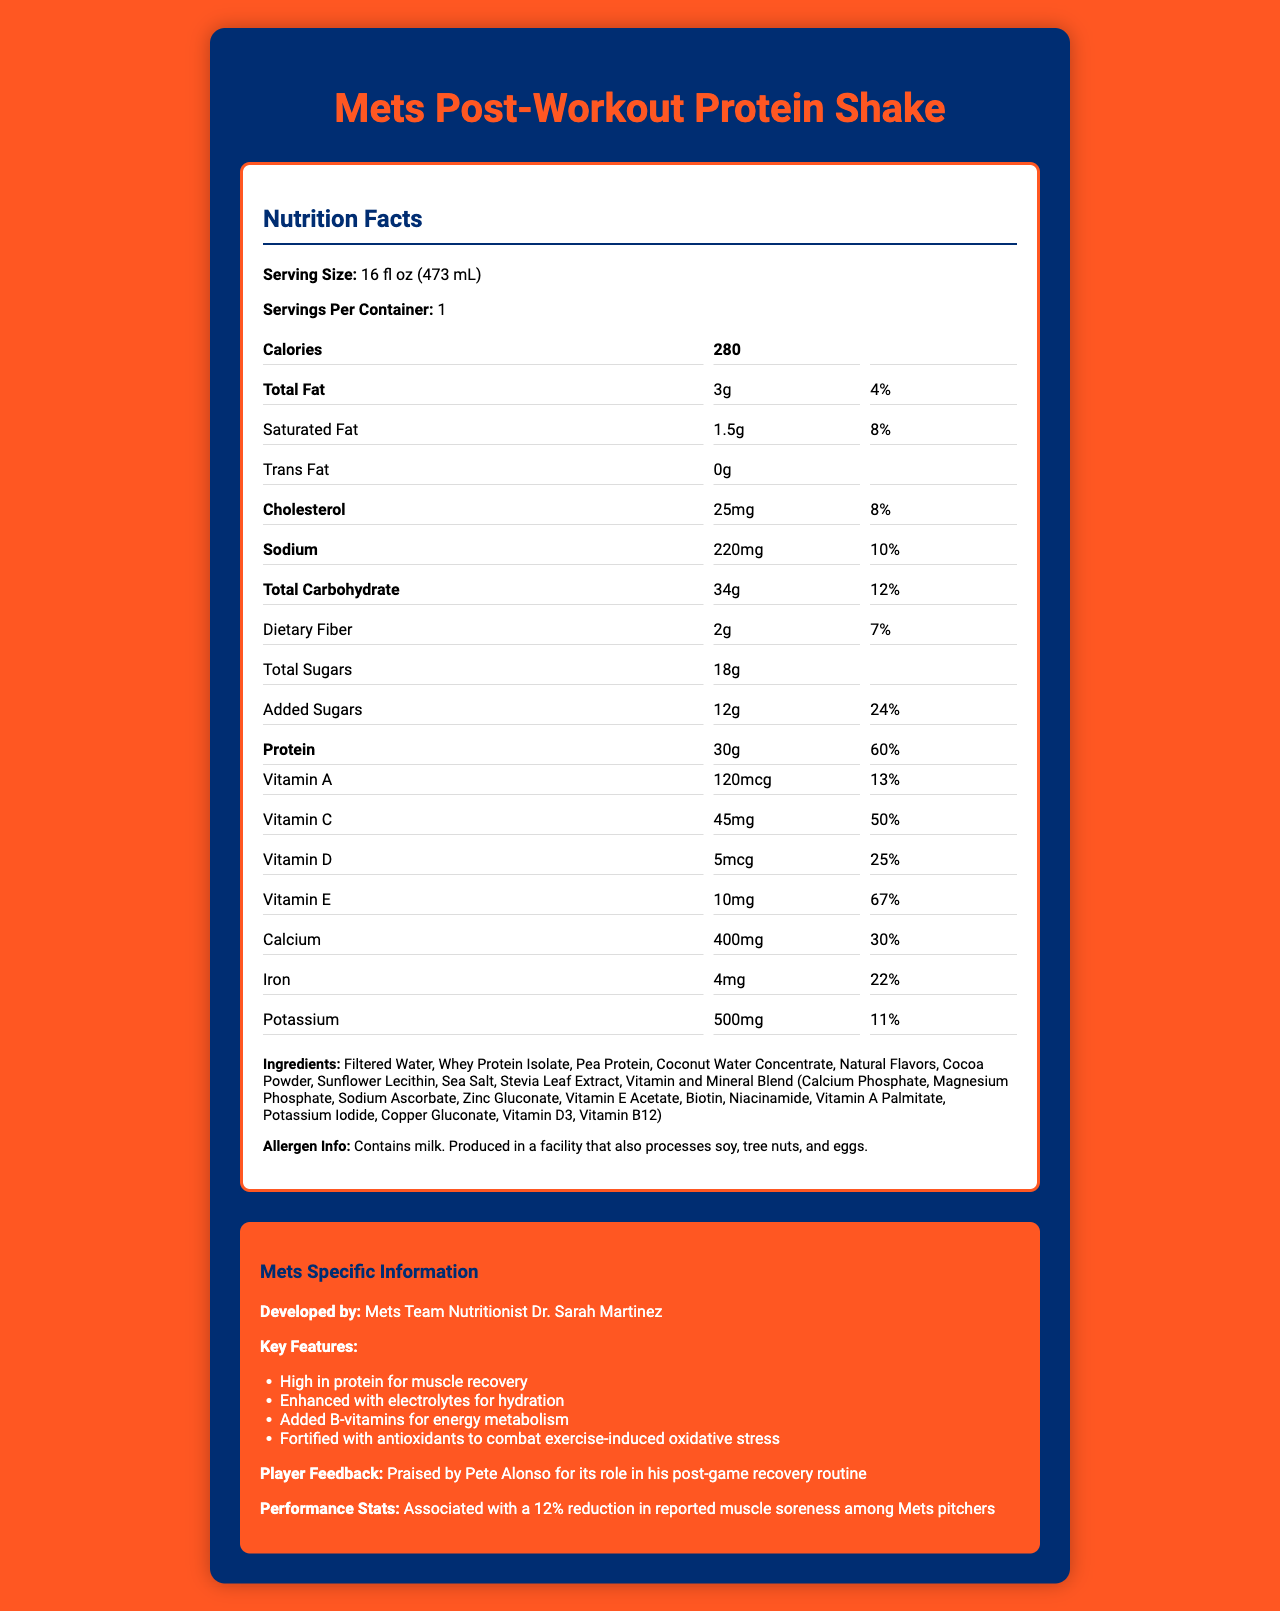what is the serving size of the protein shake? The document specifies the serving size as "16 fl oz (473 mL)".
Answer: 16 fl oz (473 mL) how many calories are in one serving of the protein shake? The document indicates that one serving contains 280 calories.
Answer: 280 what is the percentage of Daily Value for protein in the shake? The document lists the protein Daily Value percentage as 60%.
Answer: 60% which vitamin has the highest Daily Value percentage in the shake? Biotin has a Daily Value of 100%, making it the highest among the vitamins listed.
Answer: Biotin who developed the Mets team's post-workout protein shake? The document specifies that the shake was developed by Mets Team Nutritionist Dr. Sarah Martinez.
Answer: Dr. Sarah Martinez, the Mets Team Nutritionist how much sodium does one serving of the shake contain? A. 150mg B. 220mg C. 250mg The document lists sodium content as 220mg per serving.
Answer: B. 220mg what is the main ingredient of the shake? A. Pea Protein B. Whey Protein Isolate C. Coconut Water Concentrate The ingredients list shows Whey Protein Isolate as the first ingredient, indicating it is the main component.
Answer: B. Whey Protein Isolate does the shake contain any trans fat? The document states that the shake contains 0g of trans fat.
Answer: No does the shake feature electrolytes for hydration? The document's Mets Specific Information section highlights that the shake is enhanced with electrolytes for hydration.
Answer: Yes summarize the key points of the document. The document outlines the nutritional profile and Mets-specific benefits of the protein shake, emphasizing its ingredients, nutritional contributions, development by a nutritionist, and positive player feedback.
Answer: The document provides the nutrition facts and key features of the Mets' post-workout protein shake. It details the product's serving size, calories, fat, protein, carbohydrates, vitamins, and minerals. The shake was developed by the Mets Team Nutritionist Dr. Sarah Martinez and is praised for its high protein content, electrolytes, B-vitamins, and antioxidants. Player feedback indicates a reduction in muscle soreness, and it is well-received by Mets players. how much potassium is in one serving? The document specifies that one serving contains 500mg of potassium.
Answer: 500mg is the shake suitable for someone with a soy allergy? The document states that the shake is produced in a facility that also processes soy, making it unclear if it is suitable for someone with a soy allergy.
Answer: Cannot be determined how much vitamin B12 is in the shake? The document lists the vitamin B12 content as 1.8mcg.
Answer: 1.8mcg which player praised the shake for its role in his post-game recovery routine? The document includes player feedback from Pete Alonso, praising the shake's role in his recovery.
Answer: Pete Alonso how many grams of total sugars are in one serving? A. 10g B. 15g C. 18g D. 20g The document lists the total sugars content as 18g per serving.
Answer: C. 18g 